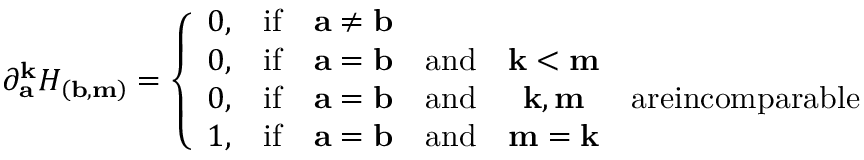Convert formula to latex. <formula><loc_0><loc_0><loc_500><loc_500>\partial _ { a } ^ { k } H _ { \left ( b , m \right ) } = \left \{ \begin{array} { c c c c c c } { 0 , } & { i f } & { a \neq b } & & & \\ { 0 , } & { i f } & { a = b } & { a n d } & { k < m } & \\ { 0 , } & { i f } & { a = b } & { a n d } & { k , m } & { a r e i n c o m p a r a b l e } \\ { 1 , } & { i f } & { a = b } & { a n d } & { m = k } & \end{array}</formula> 